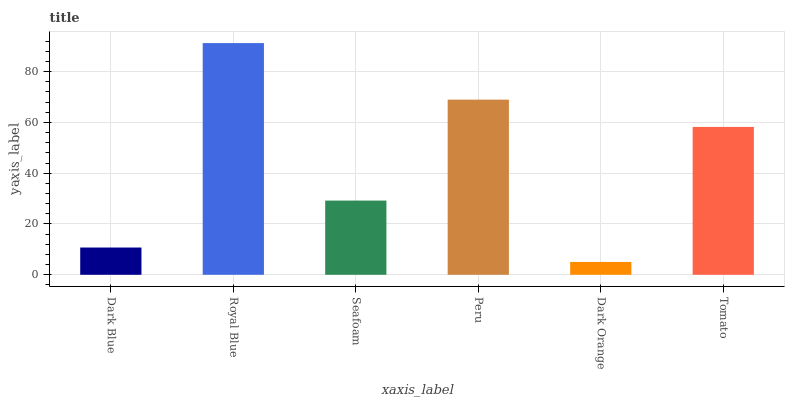Is Dark Orange the minimum?
Answer yes or no. Yes. Is Royal Blue the maximum?
Answer yes or no. Yes. Is Seafoam the minimum?
Answer yes or no. No. Is Seafoam the maximum?
Answer yes or no. No. Is Royal Blue greater than Seafoam?
Answer yes or no. Yes. Is Seafoam less than Royal Blue?
Answer yes or no. Yes. Is Seafoam greater than Royal Blue?
Answer yes or no. No. Is Royal Blue less than Seafoam?
Answer yes or no. No. Is Tomato the high median?
Answer yes or no. Yes. Is Seafoam the low median?
Answer yes or no. Yes. Is Dark Orange the high median?
Answer yes or no. No. Is Dark Orange the low median?
Answer yes or no. No. 